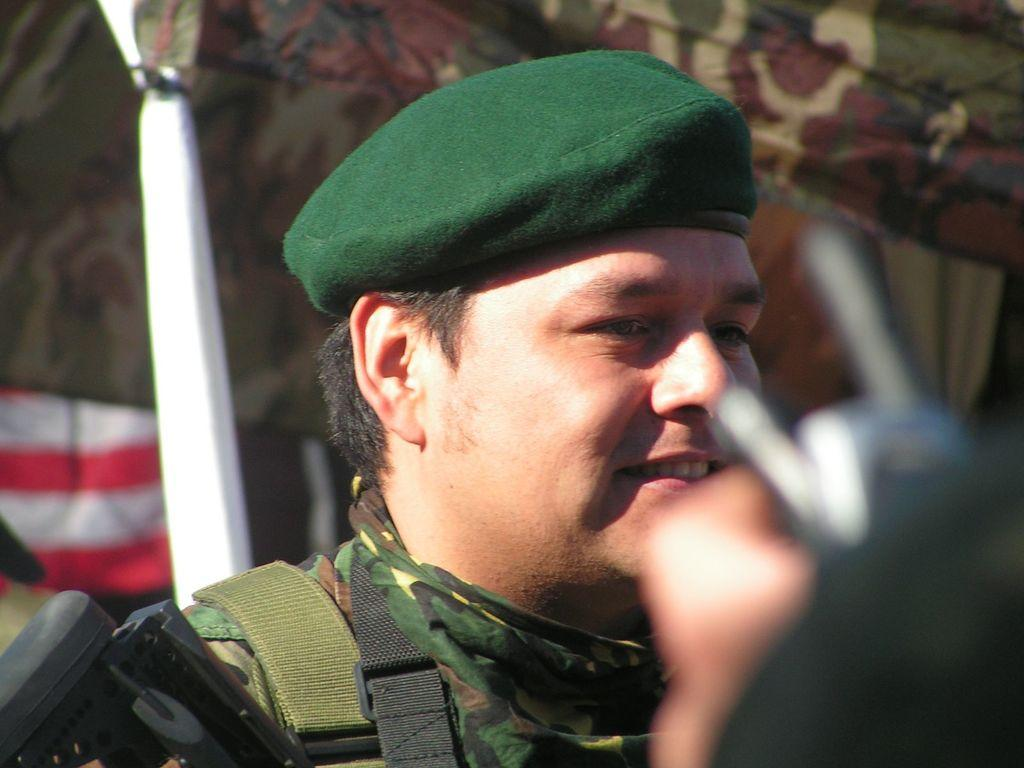What is present in the image? There is a person in the image. Can you describe the person's attire? The person is wearing a green cap. What else can be seen in the image? There is a mobile phone in the right corner of the image. What type of song is the person playing on their instrument in the image? There is no instrument or song present in the image; the person is simply wearing a green cap and there is a mobile phone in the right corner. How many snails can be seen crawling on the person's cap in the image? There are no snails present in the image; the person is wearing a green cap with no visible snails. 